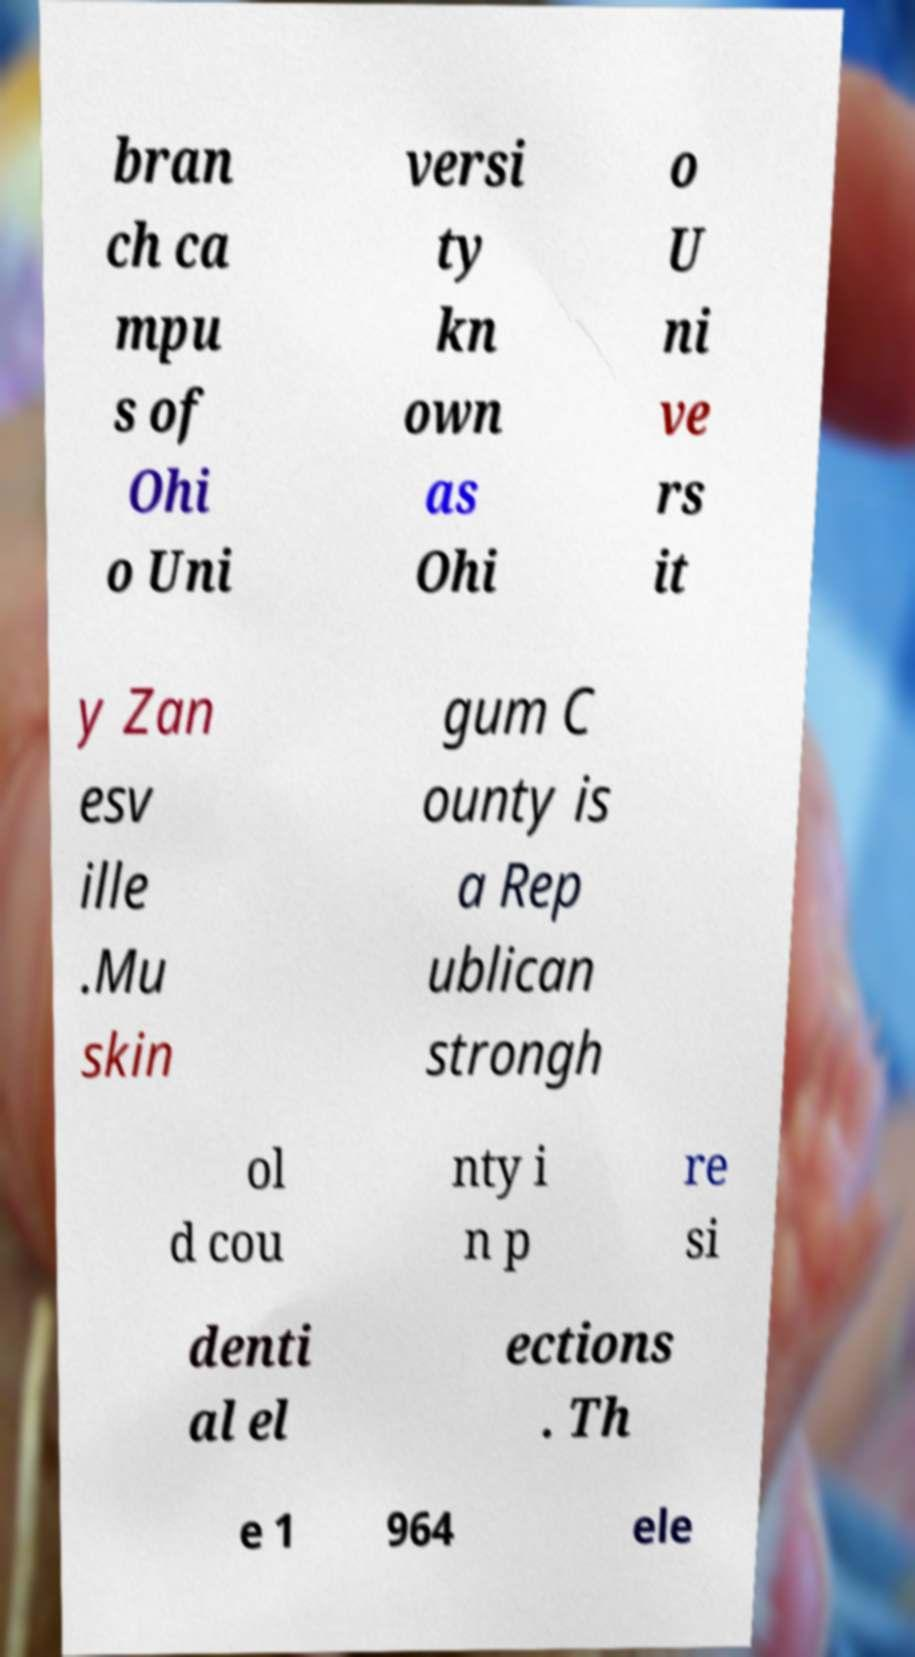There's text embedded in this image that I need extracted. Can you transcribe it verbatim? bran ch ca mpu s of Ohi o Uni versi ty kn own as Ohi o U ni ve rs it y Zan esv ille .Mu skin gum C ounty is a Rep ublican strongh ol d cou nty i n p re si denti al el ections . Th e 1 964 ele 